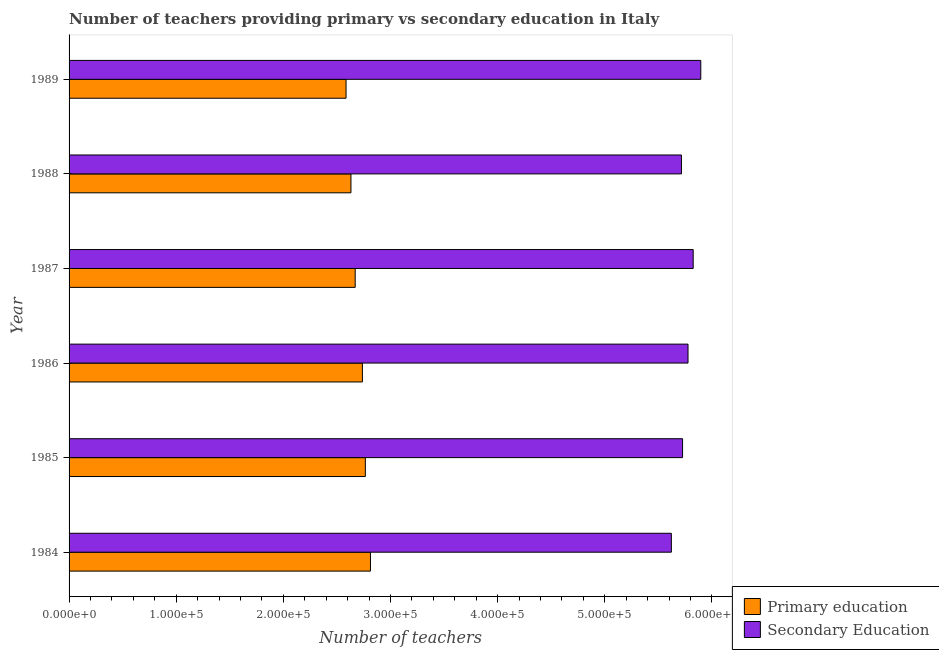Are the number of bars per tick equal to the number of legend labels?
Offer a terse response. Yes. How many bars are there on the 1st tick from the top?
Provide a short and direct response. 2. What is the label of the 1st group of bars from the top?
Ensure brevity in your answer.  1989. In how many cases, is the number of bars for a given year not equal to the number of legend labels?
Your response must be concise. 0. What is the number of primary teachers in 1989?
Your answer should be compact. 2.59e+05. Across all years, what is the maximum number of secondary teachers?
Provide a short and direct response. 5.90e+05. Across all years, what is the minimum number of secondary teachers?
Give a very brief answer. 5.62e+05. What is the total number of primary teachers in the graph?
Provide a succinct answer. 1.62e+06. What is the difference between the number of secondary teachers in 1985 and that in 1987?
Offer a terse response. -9904. What is the difference between the number of primary teachers in 1989 and the number of secondary teachers in 1985?
Your response must be concise. -3.14e+05. What is the average number of secondary teachers per year?
Offer a terse response. 5.76e+05. In the year 1988, what is the difference between the number of secondary teachers and number of primary teachers?
Your answer should be compact. 3.09e+05. In how many years, is the number of primary teachers greater than 500000 ?
Ensure brevity in your answer.  0. What is the ratio of the number of primary teachers in 1988 to that in 1989?
Provide a succinct answer. 1.02. What is the difference between the highest and the second highest number of primary teachers?
Give a very brief answer. 4758. What is the difference between the highest and the lowest number of primary teachers?
Give a very brief answer. 2.28e+04. In how many years, is the number of primary teachers greater than the average number of primary teachers taken over all years?
Make the answer very short. 3. What does the 1st bar from the top in 1986 represents?
Offer a terse response. Secondary Education. What does the 1st bar from the bottom in 1988 represents?
Your answer should be compact. Primary education. Are all the bars in the graph horizontal?
Provide a short and direct response. Yes. Does the graph contain any zero values?
Provide a succinct answer. No. Where does the legend appear in the graph?
Provide a succinct answer. Bottom right. How many legend labels are there?
Offer a terse response. 2. What is the title of the graph?
Your response must be concise. Number of teachers providing primary vs secondary education in Italy. Does "GDP" appear as one of the legend labels in the graph?
Ensure brevity in your answer.  No. What is the label or title of the X-axis?
Your answer should be very brief. Number of teachers. What is the label or title of the Y-axis?
Your answer should be very brief. Year. What is the Number of teachers in Primary education in 1984?
Offer a very short reply. 2.81e+05. What is the Number of teachers of Secondary Education in 1984?
Give a very brief answer. 5.62e+05. What is the Number of teachers in Primary education in 1985?
Give a very brief answer. 2.77e+05. What is the Number of teachers in Secondary Education in 1985?
Offer a terse response. 5.73e+05. What is the Number of teachers in Primary education in 1986?
Keep it short and to the point. 2.74e+05. What is the Number of teachers in Secondary Education in 1986?
Your answer should be very brief. 5.78e+05. What is the Number of teachers of Primary education in 1987?
Make the answer very short. 2.67e+05. What is the Number of teachers in Secondary Education in 1987?
Your answer should be compact. 5.83e+05. What is the Number of teachers of Primary education in 1988?
Make the answer very short. 2.63e+05. What is the Number of teachers in Secondary Education in 1988?
Keep it short and to the point. 5.72e+05. What is the Number of teachers of Primary education in 1989?
Your response must be concise. 2.59e+05. What is the Number of teachers in Secondary Education in 1989?
Ensure brevity in your answer.  5.90e+05. Across all years, what is the maximum Number of teachers in Primary education?
Provide a short and direct response. 2.81e+05. Across all years, what is the maximum Number of teachers of Secondary Education?
Your answer should be very brief. 5.90e+05. Across all years, what is the minimum Number of teachers of Primary education?
Make the answer very short. 2.59e+05. Across all years, what is the minimum Number of teachers of Secondary Education?
Provide a short and direct response. 5.62e+05. What is the total Number of teachers of Primary education in the graph?
Offer a terse response. 1.62e+06. What is the total Number of teachers in Secondary Education in the graph?
Offer a very short reply. 3.46e+06. What is the difference between the Number of teachers of Primary education in 1984 and that in 1985?
Ensure brevity in your answer.  4758. What is the difference between the Number of teachers of Secondary Education in 1984 and that in 1985?
Provide a succinct answer. -1.05e+04. What is the difference between the Number of teachers in Primary education in 1984 and that in 1986?
Your answer should be compact. 7511. What is the difference between the Number of teachers of Secondary Education in 1984 and that in 1986?
Ensure brevity in your answer.  -1.55e+04. What is the difference between the Number of teachers in Primary education in 1984 and that in 1987?
Provide a short and direct response. 1.42e+04. What is the difference between the Number of teachers in Secondary Education in 1984 and that in 1987?
Offer a very short reply. -2.04e+04. What is the difference between the Number of teachers in Primary education in 1984 and that in 1988?
Provide a succinct answer. 1.82e+04. What is the difference between the Number of teachers in Secondary Education in 1984 and that in 1988?
Provide a short and direct response. -9411. What is the difference between the Number of teachers in Primary education in 1984 and that in 1989?
Provide a short and direct response. 2.28e+04. What is the difference between the Number of teachers of Secondary Education in 1984 and that in 1989?
Offer a terse response. -2.75e+04. What is the difference between the Number of teachers in Primary education in 1985 and that in 1986?
Offer a very short reply. 2753. What is the difference between the Number of teachers of Secondary Education in 1985 and that in 1986?
Offer a very short reply. -5074. What is the difference between the Number of teachers of Primary education in 1985 and that in 1987?
Ensure brevity in your answer.  9488. What is the difference between the Number of teachers in Secondary Education in 1985 and that in 1987?
Give a very brief answer. -9904. What is the difference between the Number of teachers in Primary education in 1985 and that in 1988?
Offer a terse response. 1.35e+04. What is the difference between the Number of teachers of Secondary Education in 1985 and that in 1988?
Your response must be concise. 1059. What is the difference between the Number of teachers of Primary education in 1985 and that in 1989?
Offer a very short reply. 1.80e+04. What is the difference between the Number of teachers of Secondary Education in 1985 and that in 1989?
Provide a short and direct response. -1.70e+04. What is the difference between the Number of teachers of Primary education in 1986 and that in 1987?
Make the answer very short. 6735. What is the difference between the Number of teachers of Secondary Education in 1986 and that in 1987?
Give a very brief answer. -4830. What is the difference between the Number of teachers in Primary education in 1986 and that in 1988?
Your response must be concise. 1.07e+04. What is the difference between the Number of teachers of Secondary Education in 1986 and that in 1988?
Make the answer very short. 6133. What is the difference between the Number of teachers of Primary education in 1986 and that in 1989?
Ensure brevity in your answer.  1.53e+04. What is the difference between the Number of teachers in Secondary Education in 1986 and that in 1989?
Provide a short and direct response. -1.19e+04. What is the difference between the Number of teachers of Primary education in 1987 and that in 1988?
Keep it short and to the point. 3964. What is the difference between the Number of teachers in Secondary Education in 1987 and that in 1988?
Your answer should be compact. 1.10e+04. What is the difference between the Number of teachers in Primary education in 1987 and that in 1989?
Ensure brevity in your answer.  8530. What is the difference between the Number of teachers of Secondary Education in 1987 and that in 1989?
Provide a succinct answer. -7085. What is the difference between the Number of teachers of Primary education in 1988 and that in 1989?
Offer a very short reply. 4566. What is the difference between the Number of teachers in Secondary Education in 1988 and that in 1989?
Offer a terse response. -1.80e+04. What is the difference between the Number of teachers of Primary education in 1984 and the Number of teachers of Secondary Education in 1985?
Make the answer very short. -2.91e+05. What is the difference between the Number of teachers in Primary education in 1984 and the Number of teachers in Secondary Education in 1986?
Provide a succinct answer. -2.96e+05. What is the difference between the Number of teachers of Primary education in 1984 and the Number of teachers of Secondary Education in 1987?
Your response must be concise. -3.01e+05. What is the difference between the Number of teachers of Primary education in 1984 and the Number of teachers of Secondary Education in 1988?
Provide a short and direct response. -2.90e+05. What is the difference between the Number of teachers in Primary education in 1984 and the Number of teachers in Secondary Education in 1989?
Provide a succinct answer. -3.08e+05. What is the difference between the Number of teachers of Primary education in 1985 and the Number of teachers of Secondary Education in 1986?
Provide a succinct answer. -3.01e+05. What is the difference between the Number of teachers of Primary education in 1985 and the Number of teachers of Secondary Education in 1987?
Offer a terse response. -3.06e+05. What is the difference between the Number of teachers of Primary education in 1985 and the Number of teachers of Secondary Education in 1988?
Your response must be concise. -2.95e+05. What is the difference between the Number of teachers of Primary education in 1985 and the Number of teachers of Secondary Education in 1989?
Offer a terse response. -3.13e+05. What is the difference between the Number of teachers in Primary education in 1986 and the Number of teachers in Secondary Education in 1987?
Offer a very short reply. -3.09e+05. What is the difference between the Number of teachers of Primary education in 1986 and the Number of teachers of Secondary Education in 1988?
Make the answer very short. -2.98e+05. What is the difference between the Number of teachers in Primary education in 1986 and the Number of teachers in Secondary Education in 1989?
Your response must be concise. -3.16e+05. What is the difference between the Number of teachers of Primary education in 1987 and the Number of teachers of Secondary Education in 1988?
Your answer should be compact. -3.05e+05. What is the difference between the Number of teachers of Primary education in 1987 and the Number of teachers of Secondary Education in 1989?
Your response must be concise. -3.23e+05. What is the difference between the Number of teachers in Primary education in 1988 and the Number of teachers in Secondary Education in 1989?
Your response must be concise. -3.27e+05. What is the average Number of teachers of Primary education per year?
Your answer should be very brief. 2.70e+05. What is the average Number of teachers in Secondary Education per year?
Offer a terse response. 5.76e+05. In the year 1984, what is the difference between the Number of teachers in Primary education and Number of teachers in Secondary Education?
Provide a succinct answer. -2.81e+05. In the year 1985, what is the difference between the Number of teachers of Primary education and Number of teachers of Secondary Education?
Ensure brevity in your answer.  -2.96e+05. In the year 1986, what is the difference between the Number of teachers in Primary education and Number of teachers in Secondary Education?
Provide a succinct answer. -3.04e+05. In the year 1987, what is the difference between the Number of teachers of Primary education and Number of teachers of Secondary Education?
Offer a terse response. -3.16e+05. In the year 1988, what is the difference between the Number of teachers of Primary education and Number of teachers of Secondary Education?
Offer a very short reply. -3.09e+05. In the year 1989, what is the difference between the Number of teachers of Primary education and Number of teachers of Secondary Education?
Offer a terse response. -3.31e+05. What is the ratio of the Number of teachers in Primary education in 1984 to that in 1985?
Make the answer very short. 1.02. What is the ratio of the Number of teachers in Secondary Education in 1984 to that in 1985?
Ensure brevity in your answer.  0.98. What is the ratio of the Number of teachers in Primary education in 1984 to that in 1986?
Keep it short and to the point. 1.03. What is the ratio of the Number of teachers of Secondary Education in 1984 to that in 1986?
Provide a short and direct response. 0.97. What is the ratio of the Number of teachers of Primary education in 1984 to that in 1987?
Give a very brief answer. 1.05. What is the ratio of the Number of teachers of Secondary Education in 1984 to that in 1987?
Offer a very short reply. 0.96. What is the ratio of the Number of teachers in Primary education in 1984 to that in 1988?
Make the answer very short. 1.07. What is the ratio of the Number of teachers in Secondary Education in 1984 to that in 1988?
Provide a short and direct response. 0.98. What is the ratio of the Number of teachers of Primary education in 1984 to that in 1989?
Provide a succinct answer. 1.09. What is the ratio of the Number of teachers in Secondary Education in 1984 to that in 1989?
Offer a very short reply. 0.95. What is the ratio of the Number of teachers of Secondary Education in 1985 to that in 1986?
Provide a succinct answer. 0.99. What is the ratio of the Number of teachers in Primary education in 1985 to that in 1987?
Make the answer very short. 1.04. What is the ratio of the Number of teachers in Secondary Education in 1985 to that in 1987?
Keep it short and to the point. 0.98. What is the ratio of the Number of teachers of Primary education in 1985 to that in 1988?
Your answer should be very brief. 1.05. What is the ratio of the Number of teachers of Primary education in 1985 to that in 1989?
Offer a very short reply. 1.07. What is the ratio of the Number of teachers of Secondary Education in 1985 to that in 1989?
Your answer should be compact. 0.97. What is the ratio of the Number of teachers in Primary education in 1986 to that in 1987?
Offer a terse response. 1.03. What is the ratio of the Number of teachers of Secondary Education in 1986 to that in 1987?
Your answer should be very brief. 0.99. What is the ratio of the Number of teachers in Primary education in 1986 to that in 1988?
Offer a terse response. 1.04. What is the ratio of the Number of teachers in Secondary Education in 1986 to that in 1988?
Give a very brief answer. 1.01. What is the ratio of the Number of teachers of Primary education in 1986 to that in 1989?
Offer a terse response. 1.06. What is the ratio of the Number of teachers of Secondary Education in 1986 to that in 1989?
Keep it short and to the point. 0.98. What is the ratio of the Number of teachers of Primary education in 1987 to that in 1988?
Give a very brief answer. 1.02. What is the ratio of the Number of teachers in Secondary Education in 1987 to that in 1988?
Make the answer very short. 1.02. What is the ratio of the Number of teachers in Primary education in 1987 to that in 1989?
Make the answer very short. 1.03. What is the ratio of the Number of teachers in Primary education in 1988 to that in 1989?
Provide a succinct answer. 1.02. What is the ratio of the Number of teachers of Secondary Education in 1988 to that in 1989?
Give a very brief answer. 0.97. What is the difference between the highest and the second highest Number of teachers in Primary education?
Make the answer very short. 4758. What is the difference between the highest and the second highest Number of teachers in Secondary Education?
Give a very brief answer. 7085. What is the difference between the highest and the lowest Number of teachers in Primary education?
Provide a succinct answer. 2.28e+04. What is the difference between the highest and the lowest Number of teachers of Secondary Education?
Your answer should be very brief. 2.75e+04. 